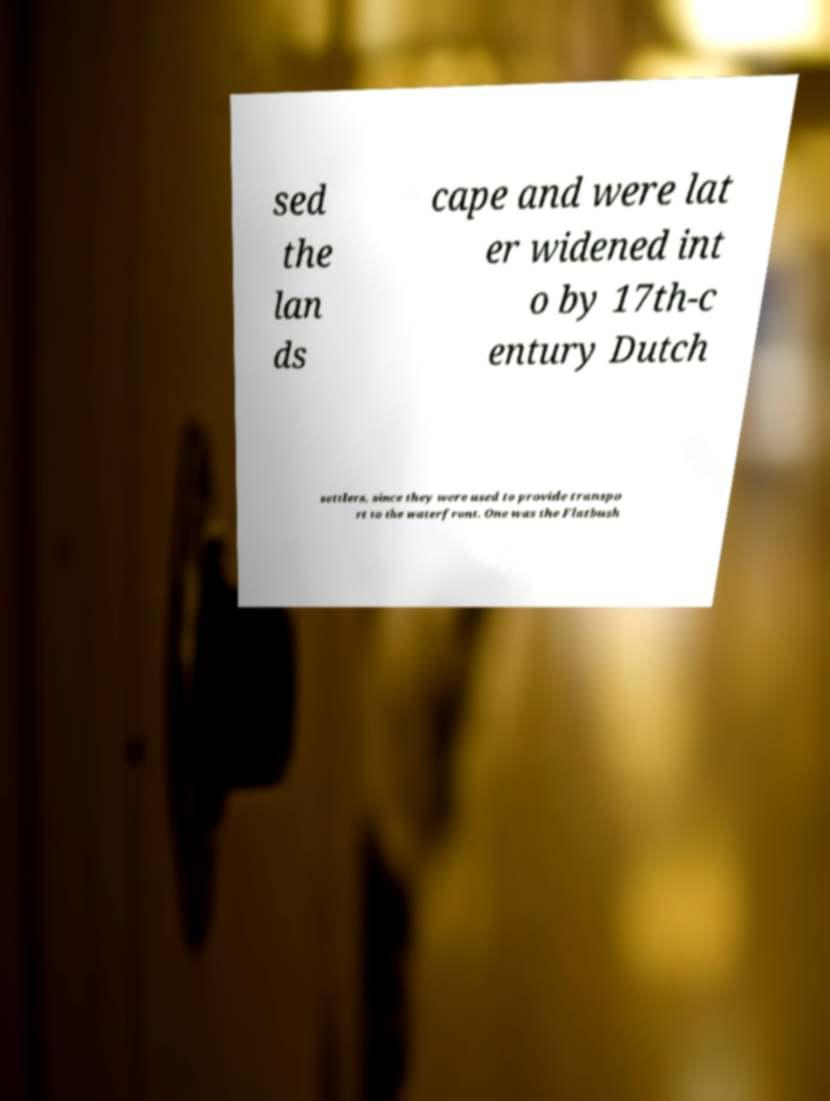Could you extract and type out the text from this image? sed the lan ds cape and were lat er widened int o by 17th-c entury Dutch settlers, since they were used to provide transpo rt to the waterfront. One was the Flatbush 